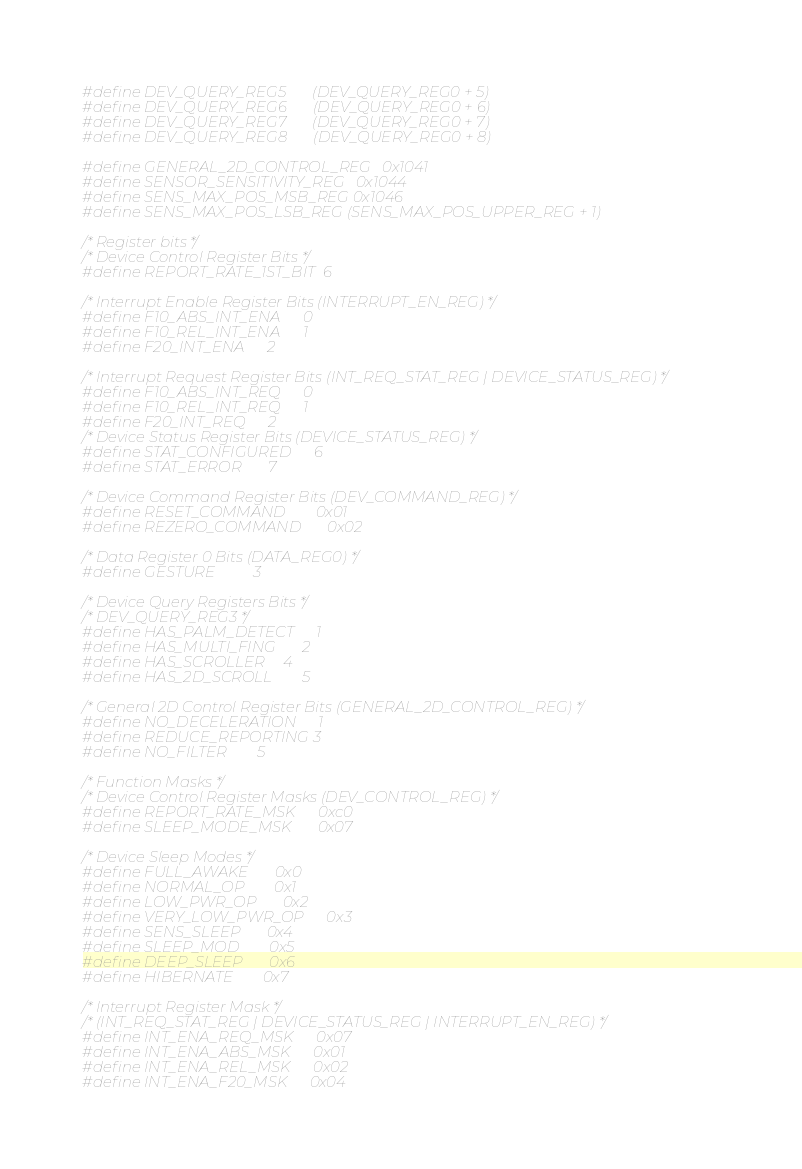<code> <loc_0><loc_0><loc_500><loc_500><_C_>#define DEV_QUERY_REG5		(DEV_QUERY_REG0 + 5)
#define DEV_QUERY_REG6		(DEV_QUERY_REG0 + 6)
#define DEV_QUERY_REG7		(DEV_QUERY_REG0 + 7)
#define DEV_QUERY_REG8		(DEV_QUERY_REG0 + 8)

#define GENERAL_2D_CONTROL_REG	0x1041
#define SENSOR_SENSITIVITY_REG	0x1044
#define SENS_MAX_POS_MSB_REG	0x1046
#define SENS_MAX_POS_LSB_REG	(SENS_MAX_POS_UPPER_REG + 1)

/* Register bits */
/* Device Control Register Bits */
#define REPORT_RATE_1ST_BIT	6

/* Interrupt Enable Register Bits (INTERRUPT_EN_REG) */
#define F10_ABS_INT_ENA		0
#define F10_REL_INT_ENA		1
#define F20_INT_ENA		2

/* Interrupt Request Register Bits (INT_REQ_STAT_REG | DEVICE_STATUS_REG) */
#define F10_ABS_INT_REQ		0
#define F10_REL_INT_REQ		1
#define F20_INT_REQ		2
/* Device Status Register Bits (DEVICE_STATUS_REG) */
#define STAT_CONFIGURED		6
#define STAT_ERROR		7

/* Device Command Register Bits (DEV_COMMAND_REG) */
#define RESET_COMMAND		0x01
#define REZERO_COMMAND		0x02

/* Data Register 0 Bits (DATA_REG0) */
#define GESTURE			3

/* Device Query Registers Bits */
/* DEV_QUERY_REG3 */
#define HAS_PALM_DETECT		1
#define HAS_MULTI_FING		2
#define HAS_SCROLLER		4
#define HAS_2D_SCROLL		5

/* General 2D Control Register Bits (GENERAL_2D_CONTROL_REG) */
#define NO_DECELERATION		1
#define REDUCE_REPORTING	3
#define NO_FILTER		5

/* Function Masks */
/* Device Control Register Masks (DEV_CONTROL_REG) */
#define REPORT_RATE_MSK		0xc0
#define SLEEP_MODE_MSK		0x07

/* Device Sleep Modes */
#define FULL_AWAKE		0x0
#define NORMAL_OP		0x1
#define LOW_PWR_OP		0x2
#define VERY_LOW_PWR_OP		0x3
#define SENS_SLEEP		0x4
#define SLEEP_MOD		0x5
#define DEEP_SLEEP		0x6
#define HIBERNATE		0x7

/* Interrupt Register Mask */
/* (INT_REQ_STAT_REG | DEVICE_STATUS_REG | INTERRUPT_EN_REG) */
#define INT_ENA_REQ_MSK		0x07
#define INT_ENA_ABS_MSK		0x01
#define INT_ENA_REL_MSK		0x02
#define INT_ENA_F20_MSK		0x04
</code> 